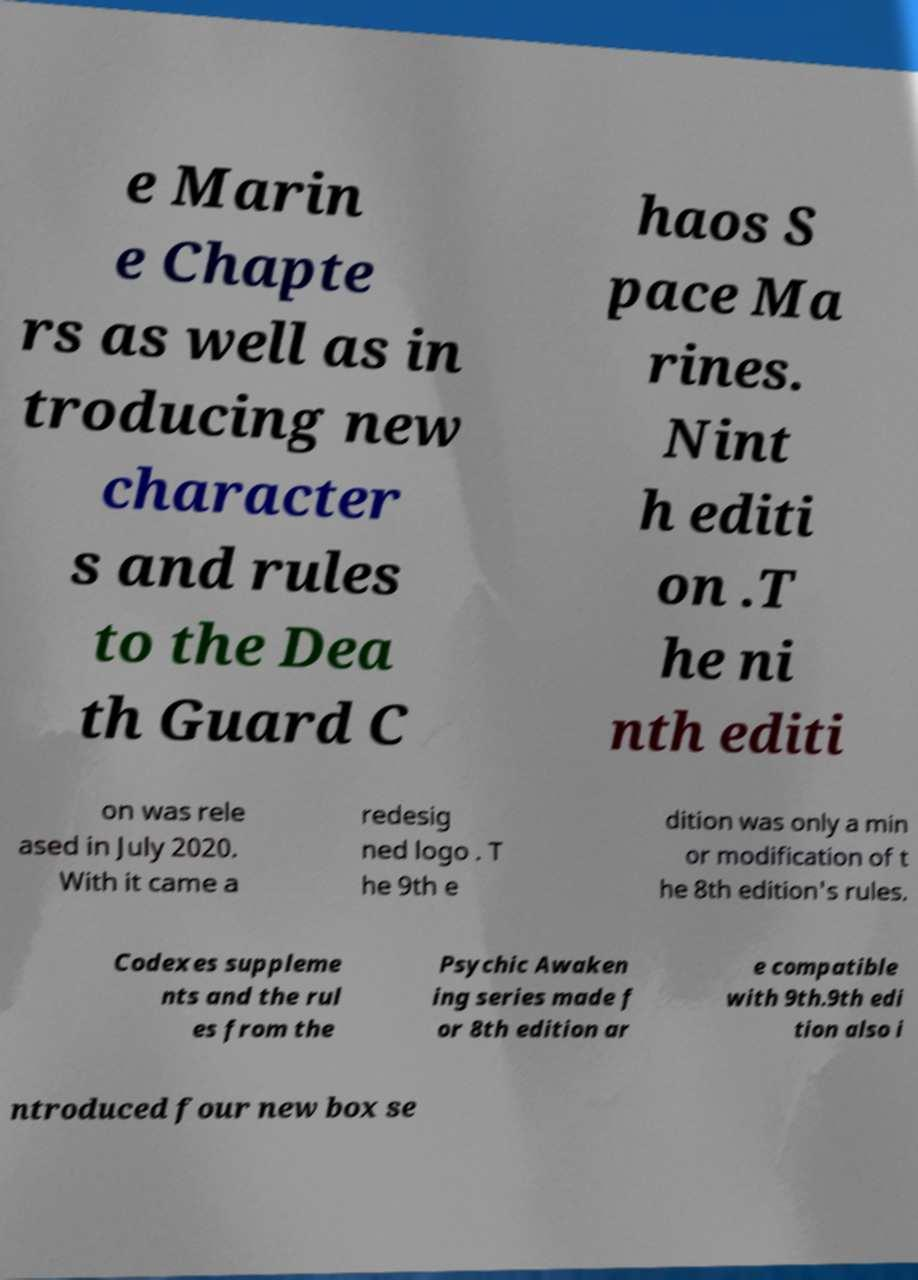Please identify and transcribe the text found in this image. e Marin e Chapte rs as well as in troducing new character s and rules to the Dea th Guard C haos S pace Ma rines. Nint h editi on .T he ni nth editi on was rele ased in July 2020. With it came a redesig ned logo . T he 9th e dition was only a min or modification of t he 8th edition's rules. Codexes suppleme nts and the rul es from the Psychic Awaken ing series made f or 8th edition ar e compatible with 9th.9th edi tion also i ntroduced four new box se 